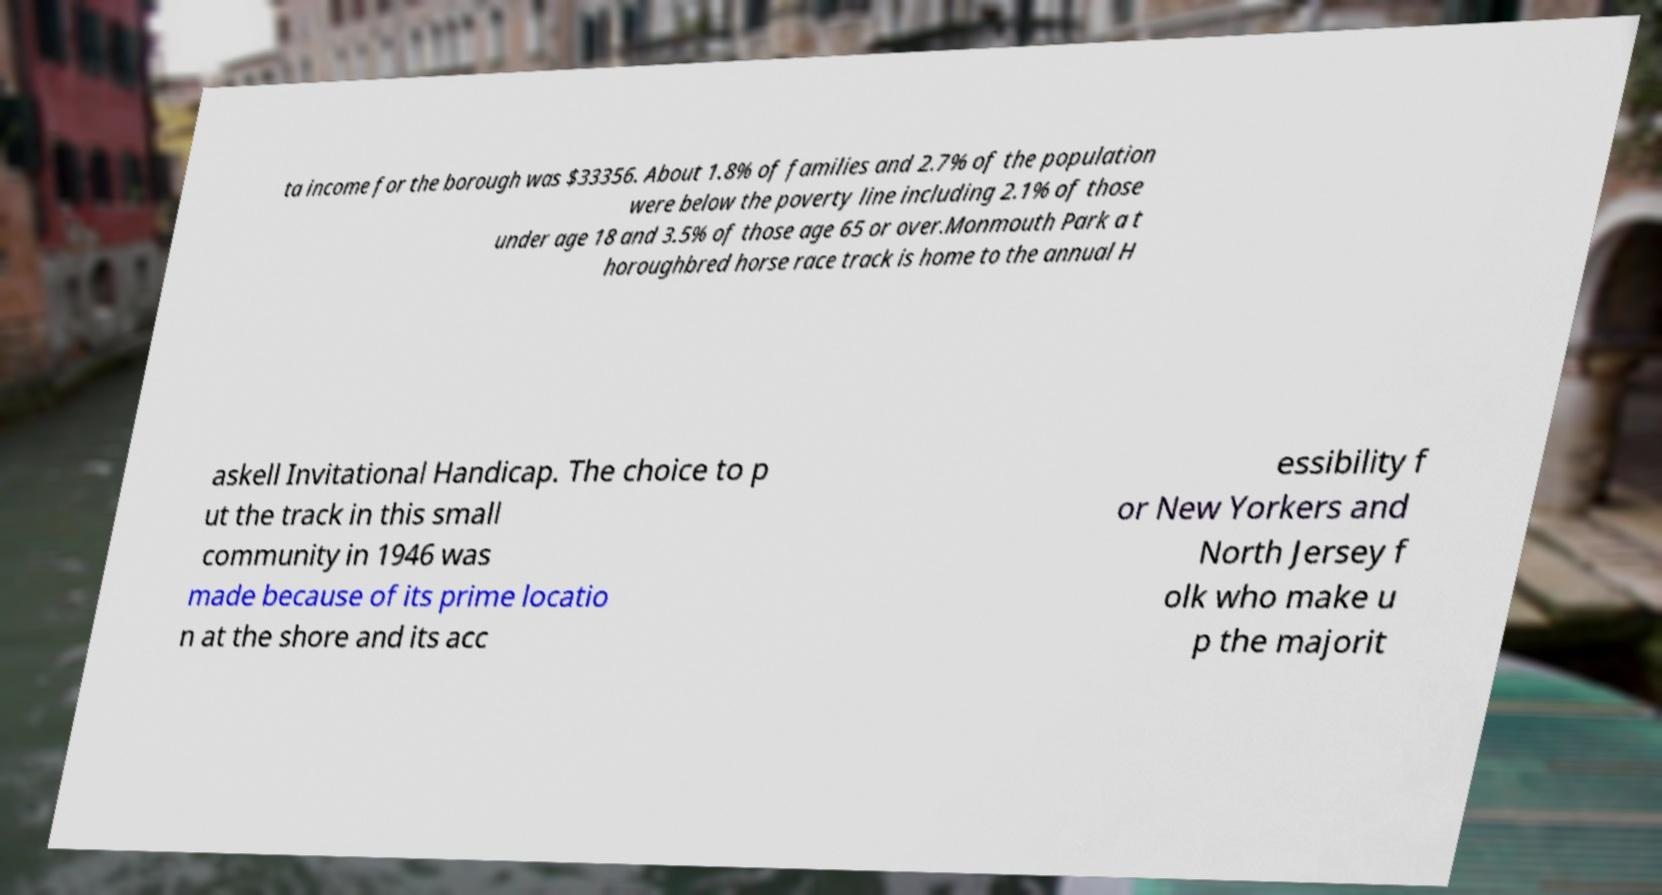For documentation purposes, I need the text within this image transcribed. Could you provide that? ta income for the borough was $33356. About 1.8% of families and 2.7% of the population were below the poverty line including 2.1% of those under age 18 and 3.5% of those age 65 or over.Monmouth Park a t horoughbred horse race track is home to the annual H askell Invitational Handicap. The choice to p ut the track in this small community in 1946 was made because of its prime locatio n at the shore and its acc essibility f or New Yorkers and North Jersey f olk who make u p the majorit 